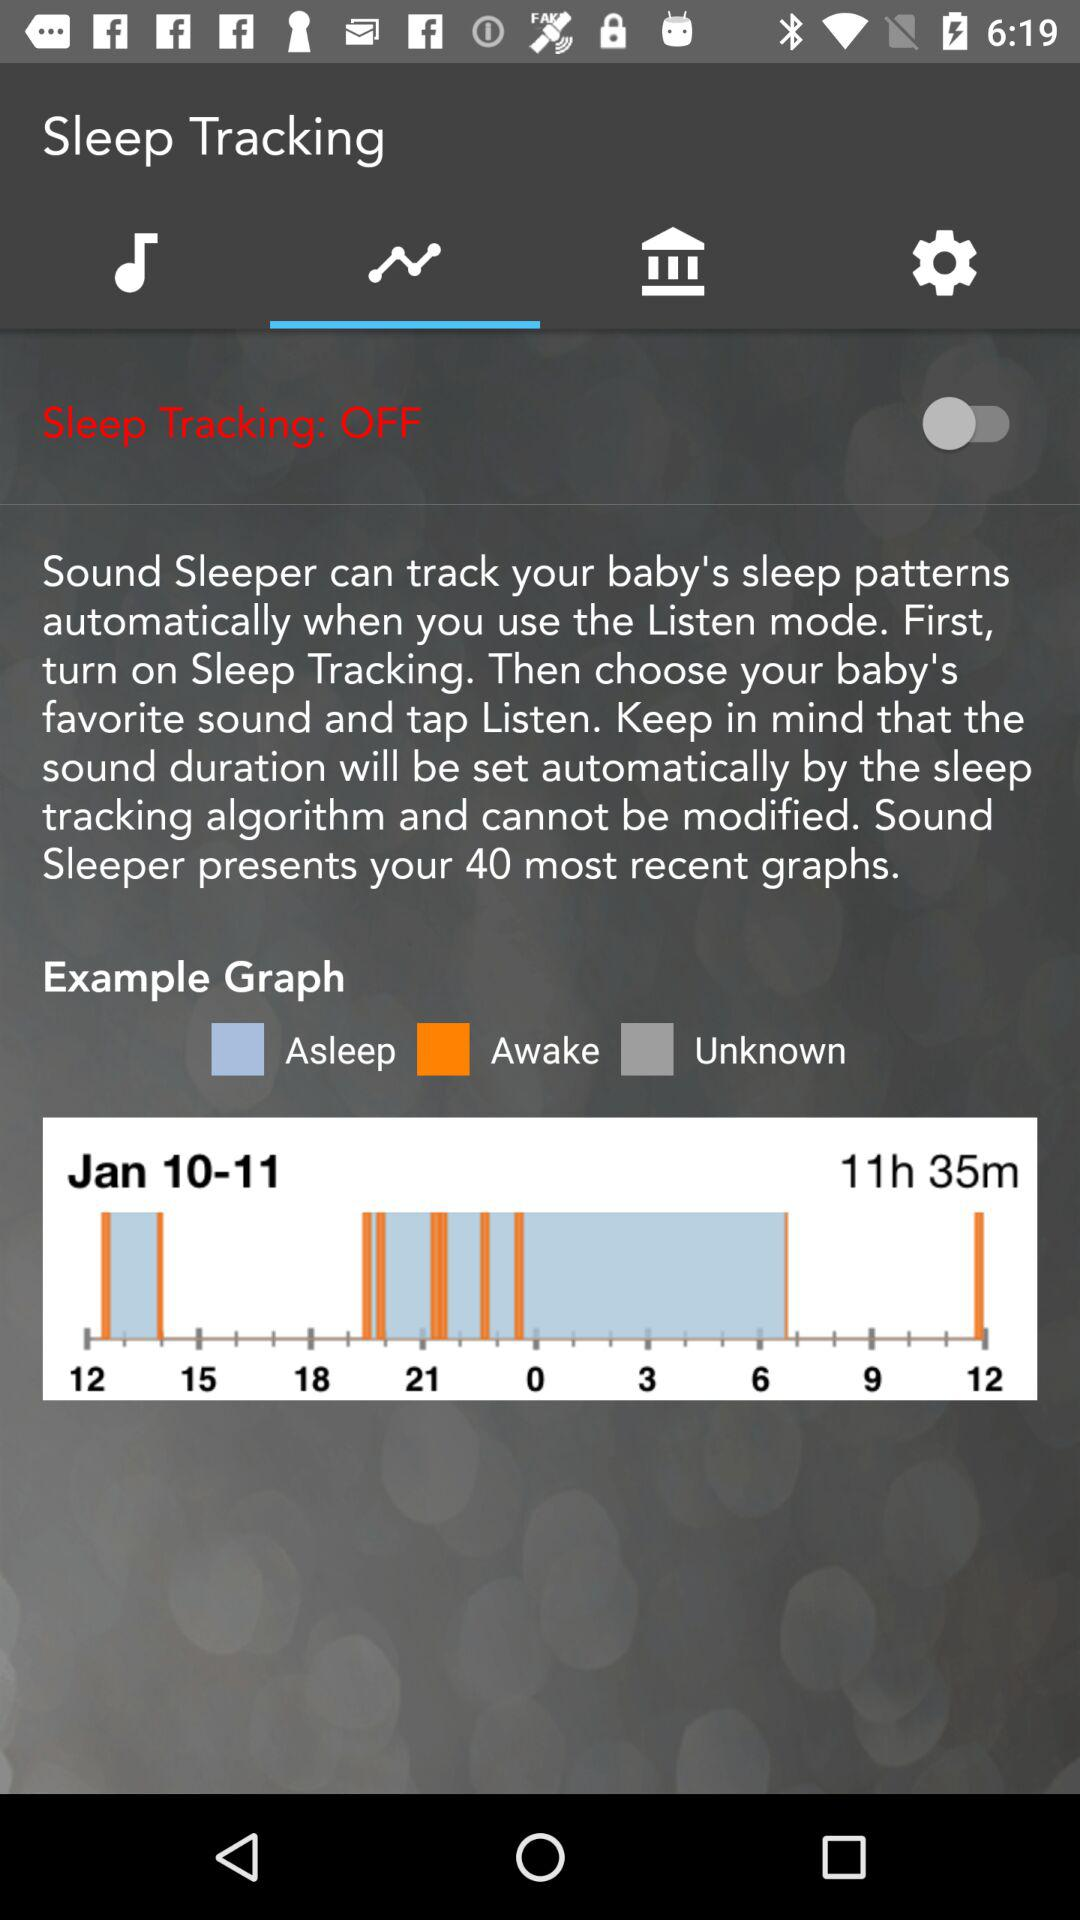How many hours and minutes of sleep data does the graph show?
Answer the question using a single word or phrase. 11h 35m 